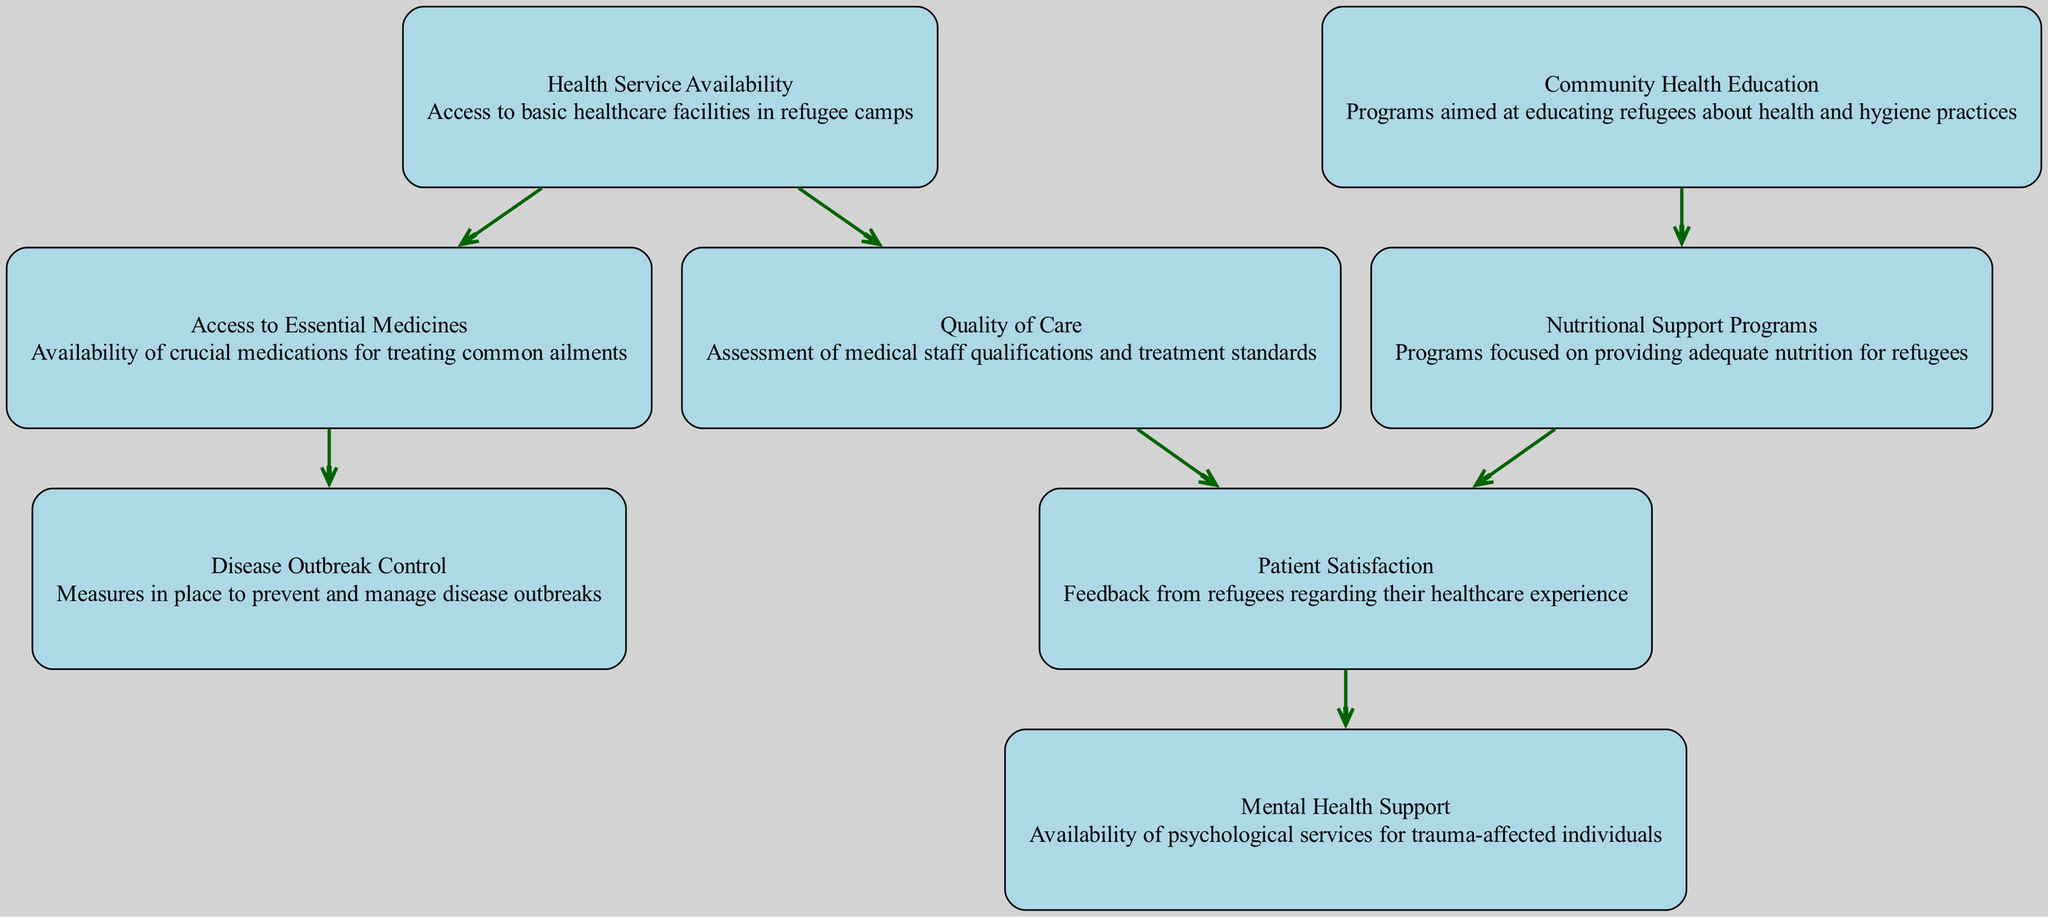What is the total number of nodes in the diagram? The diagram includes eight distinct aspects related to health services, which are represented as nodes. By counting these nodes: Health Service Availability, Quality of Care, Patient Satisfaction, Disease Outbreak Control, Mental Health Support, Access to Essential Medicines, Nutritional Support Programs, and Community Health Education, we find that the total is eight.
Answer: 8 What edge connects Quality of Care to Patient Satisfaction? The directed graph shows that there is a direct connection (edge) from Quality of Care to Patient Satisfaction, indicating that the quality of care affects how patients feel about their healthcare. This is seen explicitly in the edge between these two nodes in the diagram.
Answer: Quality of Care to Patient Satisfaction Which node is a source for Nutritional Support Programs? The source for Nutritional Support Programs is Community Health Education, as indicated by the directed edge from Community Health Education leading to Nutritional Support Programs in the diagram, showing that community health efforts influence nutrition support.
Answer: Community Health Education How many edges are there in total? The graph presents various relationships among the nodes, represented as edges. By counting the connections: from Health Service Availability to Quality of Care, from Quality of Care to Patient Satisfaction, and so on, we find a total of seven edges in the diagram.
Answer: 7 What does the edge from Access to Essential Medicines lead to? The edge from Access to Essential Medicines leads to Disease Outbreak Control, indicating that having access to essential medicines contributes to the ability to control disease outbreaks. This connection is present between the corresponding nodes in the graph.
Answer: Disease Outbreak Control What is the relationship between Patient Satisfaction and Mental Health Support? The diagram indicates a direct relationship where Patient Satisfaction influences Mental Health Support, suggesting that higher satisfaction with health services leads to better availability or acknowledgment of mental health services in the context of refugee camps.
Answer: Patient Satisfaction to Mental Health Support Which node is directly connected to Health Service Availability? Health Service Availability is directly connected to two nodes: Quality of Care and Access to Essential Medicines. This shows the foundational role of availability in affecting both care quality and medicine access.
Answer: Quality of Care, Access to Essential Medicines How does Nutritional Support Programs influence Patient Satisfaction? The directed edge from Nutritional Support Programs to Patient Satisfaction indicates that the effectiveness or existence of nutritional support has a positive impact on how satisfied refugees are with their healthcare. This relationship can be observed in the diagram.
Answer: Nutritional Support Programs to Patient Satisfaction 